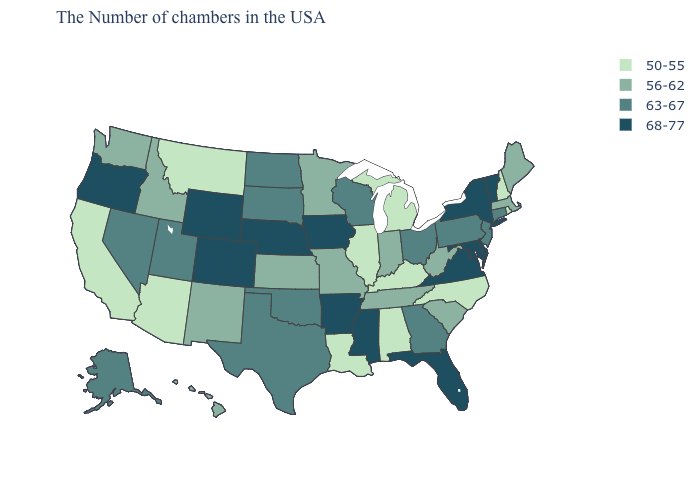Which states have the lowest value in the South?
Write a very short answer. North Carolina, Kentucky, Alabama, Louisiana. Which states hav the highest value in the South?
Short answer required. Delaware, Maryland, Virginia, Florida, Mississippi, Arkansas. What is the value of Hawaii?
Quick response, please. 56-62. What is the value of South Dakota?
Write a very short answer. 63-67. What is the value of Missouri?
Write a very short answer. 56-62. What is the highest value in the MidWest ?
Concise answer only. 68-77. Does the map have missing data?
Be succinct. No. What is the highest value in the USA?
Keep it brief. 68-77. Does Rhode Island have the lowest value in the USA?
Answer briefly. Yes. Among the states that border Connecticut , does Massachusetts have the lowest value?
Answer briefly. No. Does the first symbol in the legend represent the smallest category?
Be succinct. Yes. Name the states that have a value in the range 63-67?
Answer briefly. Connecticut, New Jersey, Pennsylvania, Ohio, Georgia, Wisconsin, Oklahoma, Texas, South Dakota, North Dakota, Utah, Nevada, Alaska. Among the states that border Vermont , does New York have the lowest value?
Write a very short answer. No. Does the first symbol in the legend represent the smallest category?
Write a very short answer. Yes. Is the legend a continuous bar?
Write a very short answer. No. 